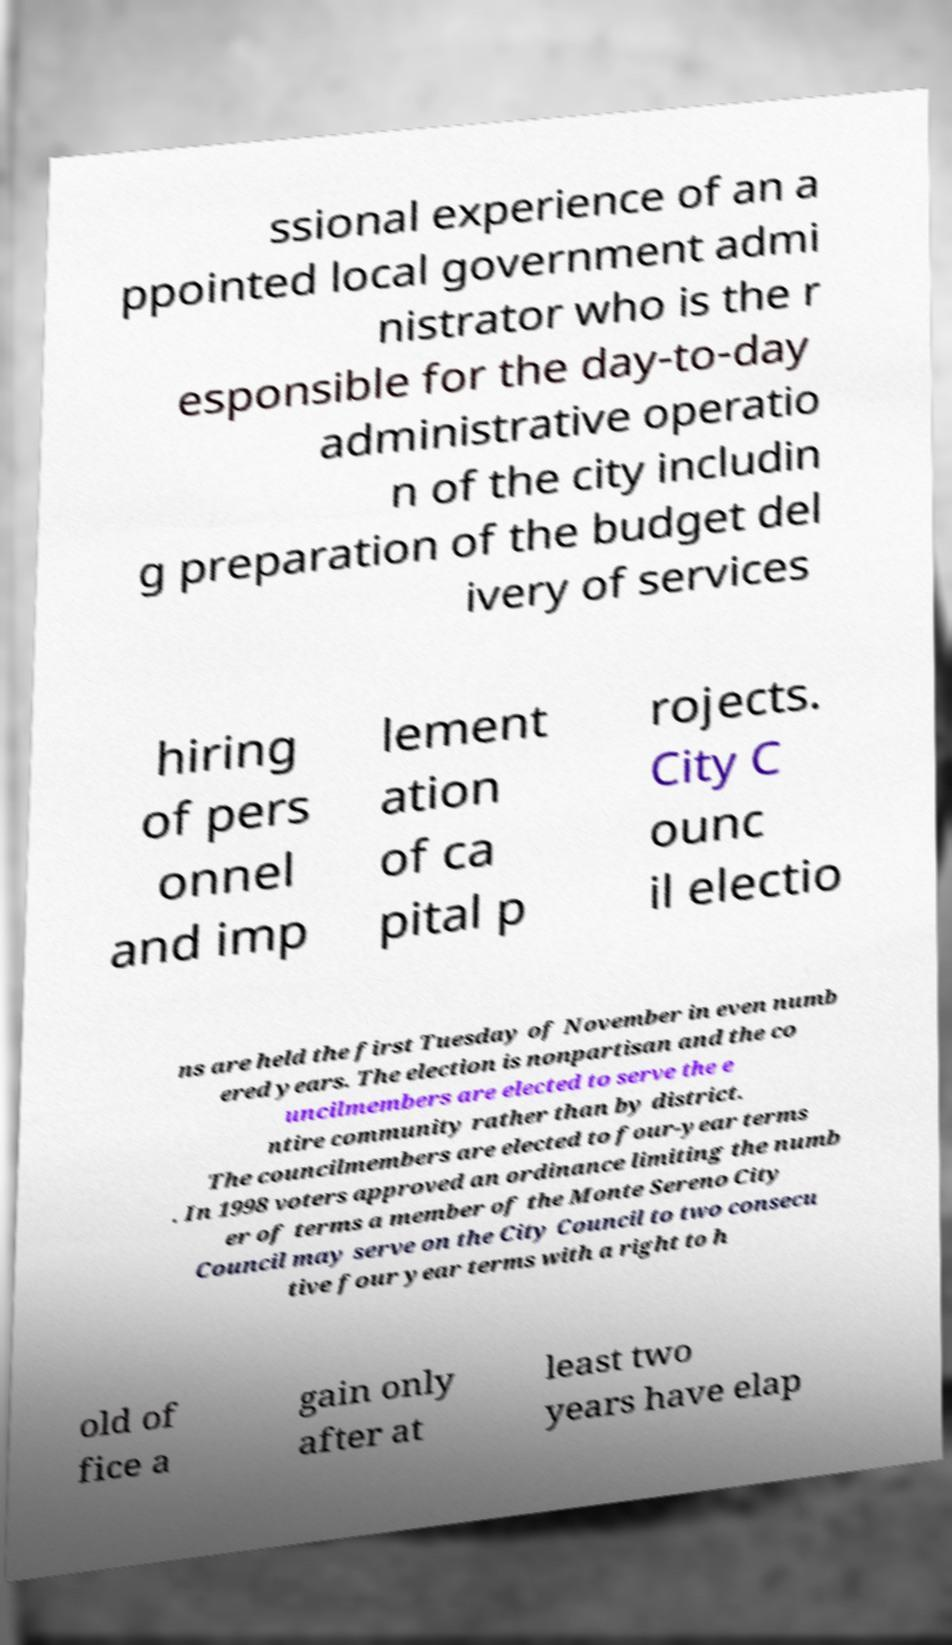For documentation purposes, I need the text within this image transcribed. Could you provide that? ssional experience of an a ppointed local government admi nistrator who is the r esponsible for the day-to-day administrative operatio n of the city includin g preparation of the budget del ivery of services hiring of pers onnel and imp lement ation of ca pital p rojects. City C ounc il electio ns are held the first Tuesday of November in even numb ered years. The election is nonpartisan and the co uncilmembers are elected to serve the e ntire community rather than by district. The councilmembers are elected to four-year terms . In 1998 voters approved an ordinance limiting the numb er of terms a member of the Monte Sereno City Council may serve on the City Council to two consecu tive four year terms with a right to h old of fice a gain only after at least two years have elap 